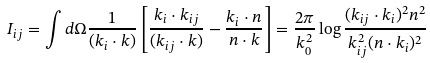Convert formula to latex. <formula><loc_0><loc_0><loc_500><loc_500>I _ { i j } = \int d \Omega \frac { 1 } { ( k _ { i } \cdot k ) } \left [ \frac { k _ { i } \cdot k _ { i j } } { ( k _ { i j } \cdot k ) } - \frac { k _ { i } \cdot n } { n \cdot k } \right ] = \frac { 2 \pi } { k _ { 0 } ^ { 2 } } \log \frac { ( k _ { i j } \cdot k _ { i } ) ^ { 2 } n ^ { 2 } } { k _ { i j } ^ { 2 } ( n \cdot k _ { i } ) ^ { 2 } }</formula> 